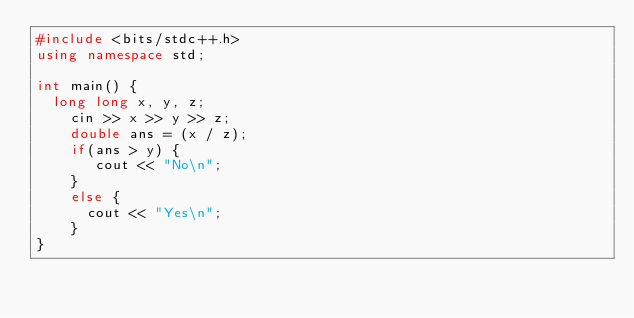<code> <loc_0><loc_0><loc_500><loc_500><_C++_>#include <bits/stdc++.h>
using namespace std;

int main() {
 	long long x, y, z;
  	cin >> x >> y >> z;
  	double ans = (x / z);
  	if(ans > y) {
     	 cout << "No\n";
    }
  	else {
     	cout << "Yes\n";
    }
}
</code> 